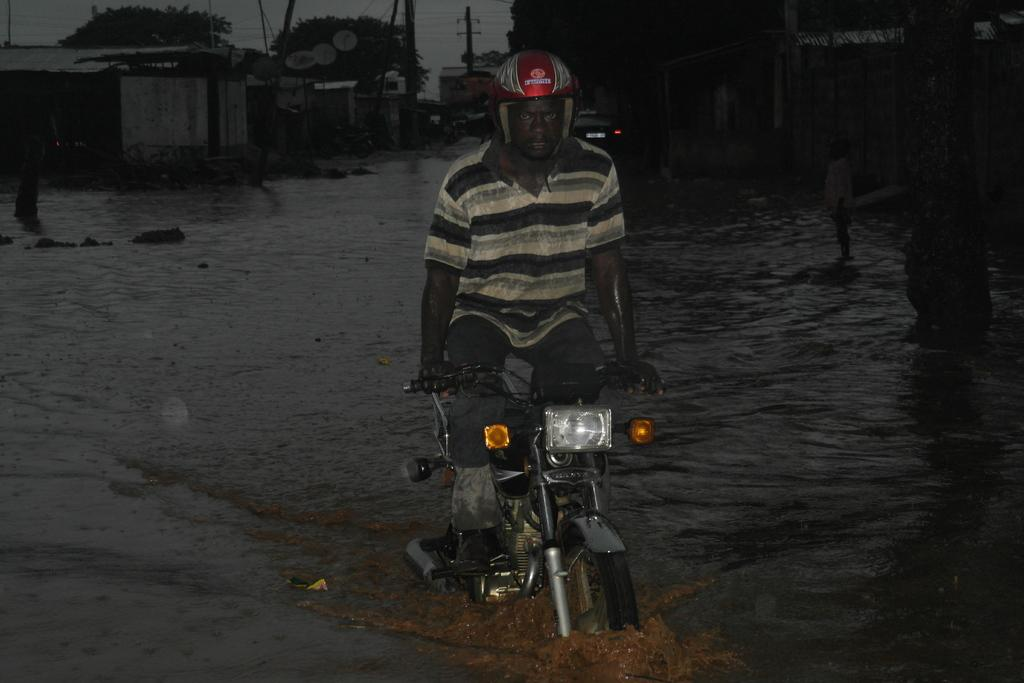What is the man doing in the water in the image? The man is riding a motorcycle in the water. What safety gear is the man wearing? The man is wearing a helmet. What type of structures can be seen in the image? There are houses visible in the image. What type of vegetation is present in the image? There are trees in the image. What other vehicle is present in the image? There is a car in the image. What utility infrastructure is present in the image? There are electric poles in the image. What type of wool is being spun by the man on the motorcycle in the image? There is no wool or spinning activity present in the image; the man is riding a motorcycle in the water. What is causing the man on the motorcycle to feel anger in the image? There is no indication of anger or any emotional state in the image; the man is simply riding a motorcycle in the water. 